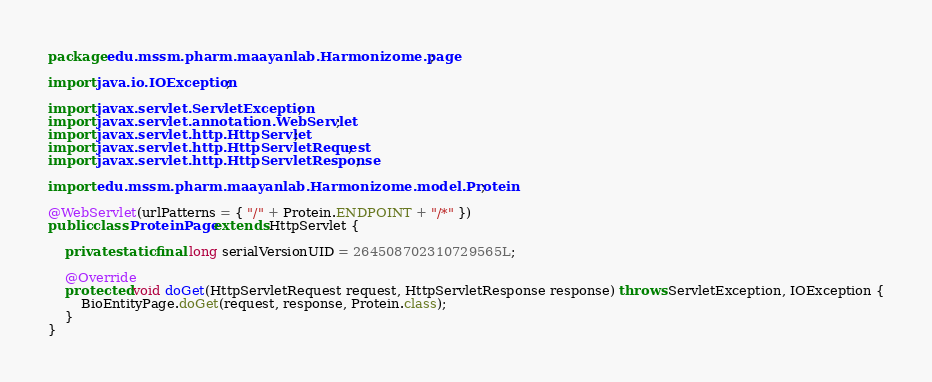Convert code to text. <code><loc_0><loc_0><loc_500><loc_500><_Java_>package edu.mssm.pharm.maayanlab.Harmonizome.page;

import java.io.IOException;

import javax.servlet.ServletException;
import javax.servlet.annotation.WebServlet;
import javax.servlet.http.HttpServlet;
import javax.servlet.http.HttpServletRequest;
import javax.servlet.http.HttpServletResponse;

import edu.mssm.pharm.maayanlab.Harmonizome.model.Protein;

@WebServlet(urlPatterns = { "/" + Protein.ENDPOINT + "/*" })
public class ProteinPage extends HttpServlet {

	private static final long serialVersionUID = 264508702310729565L;

	@Override
	protected void doGet(HttpServletRequest request, HttpServletResponse response) throws ServletException, IOException {
		BioEntityPage.doGet(request, response, Protein.class);
	}
}</code> 